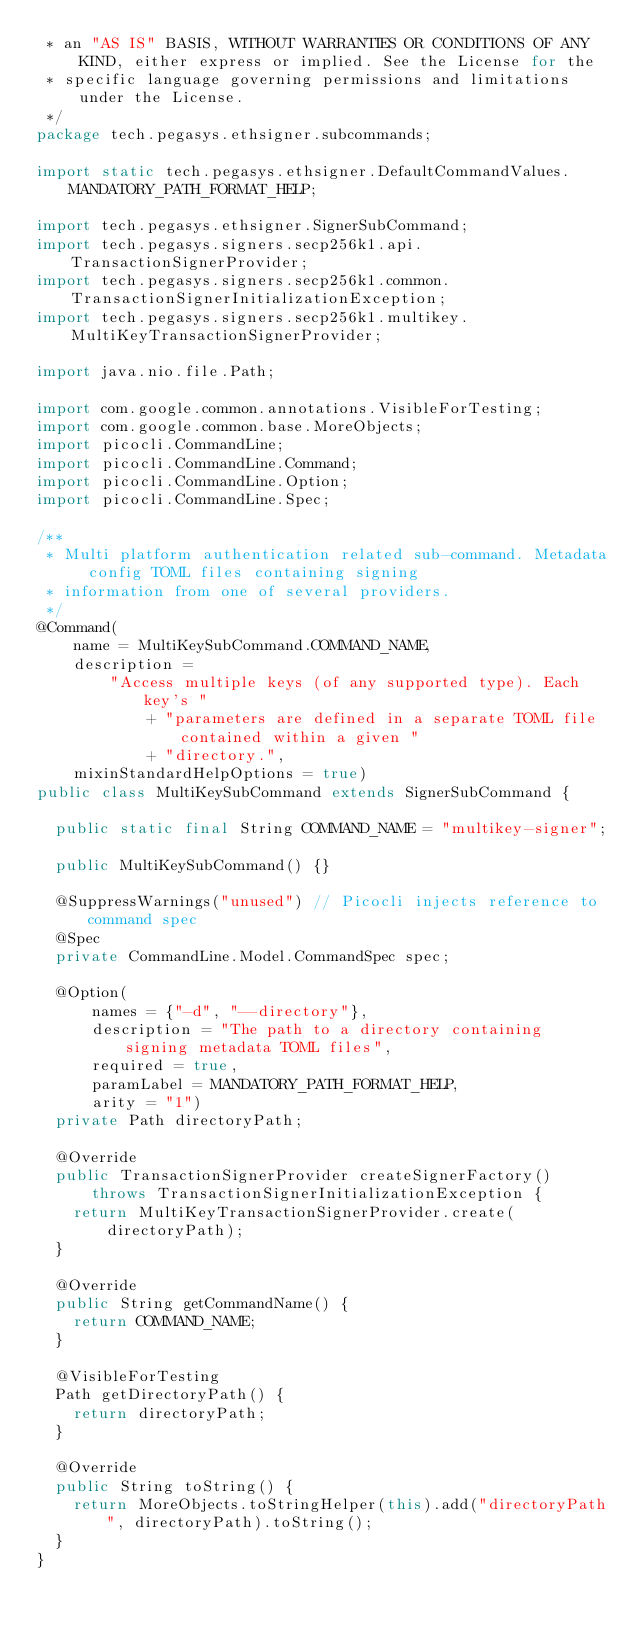<code> <loc_0><loc_0><loc_500><loc_500><_Java_> * an "AS IS" BASIS, WITHOUT WARRANTIES OR CONDITIONS OF ANY KIND, either express or implied. See the License for the
 * specific language governing permissions and limitations under the License.
 */
package tech.pegasys.ethsigner.subcommands;

import static tech.pegasys.ethsigner.DefaultCommandValues.MANDATORY_PATH_FORMAT_HELP;

import tech.pegasys.ethsigner.SignerSubCommand;
import tech.pegasys.signers.secp256k1.api.TransactionSignerProvider;
import tech.pegasys.signers.secp256k1.common.TransactionSignerInitializationException;
import tech.pegasys.signers.secp256k1.multikey.MultiKeyTransactionSignerProvider;

import java.nio.file.Path;

import com.google.common.annotations.VisibleForTesting;
import com.google.common.base.MoreObjects;
import picocli.CommandLine;
import picocli.CommandLine.Command;
import picocli.CommandLine.Option;
import picocli.CommandLine.Spec;

/**
 * Multi platform authentication related sub-command. Metadata config TOML files containing signing
 * information from one of several providers.
 */
@Command(
    name = MultiKeySubCommand.COMMAND_NAME,
    description =
        "Access multiple keys (of any supported type). Each key's "
            + "parameters are defined in a separate TOML file contained within a given "
            + "directory.",
    mixinStandardHelpOptions = true)
public class MultiKeySubCommand extends SignerSubCommand {

  public static final String COMMAND_NAME = "multikey-signer";

  public MultiKeySubCommand() {}

  @SuppressWarnings("unused") // Picocli injects reference to command spec
  @Spec
  private CommandLine.Model.CommandSpec spec;

  @Option(
      names = {"-d", "--directory"},
      description = "The path to a directory containing signing metadata TOML files",
      required = true,
      paramLabel = MANDATORY_PATH_FORMAT_HELP,
      arity = "1")
  private Path directoryPath;

  @Override
  public TransactionSignerProvider createSignerFactory()
      throws TransactionSignerInitializationException {
    return MultiKeyTransactionSignerProvider.create(directoryPath);
  }

  @Override
  public String getCommandName() {
    return COMMAND_NAME;
  }

  @VisibleForTesting
  Path getDirectoryPath() {
    return directoryPath;
  }

  @Override
  public String toString() {
    return MoreObjects.toStringHelper(this).add("directoryPath", directoryPath).toString();
  }
}
</code> 